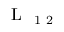<formula> <loc_0><loc_0><loc_500><loc_500>L _ { 1 2 }</formula> 